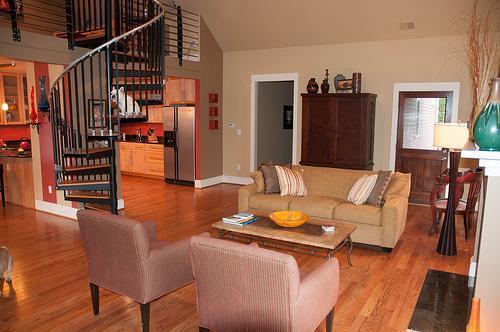How many tables are there?
Give a very brief answer. 1. 